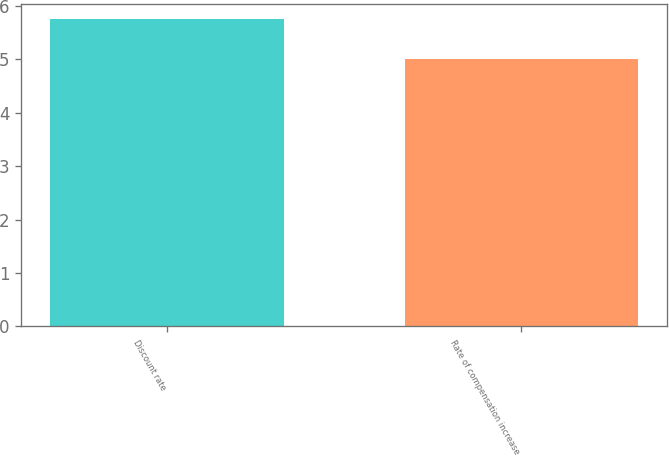<chart> <loc_0><loc_0><loc_500><loc_500><bar_chart><fcel>Discount rate<fcel>Rate of compensation increase<nl><fcel>5.75<fcel>5<nl></chart> 